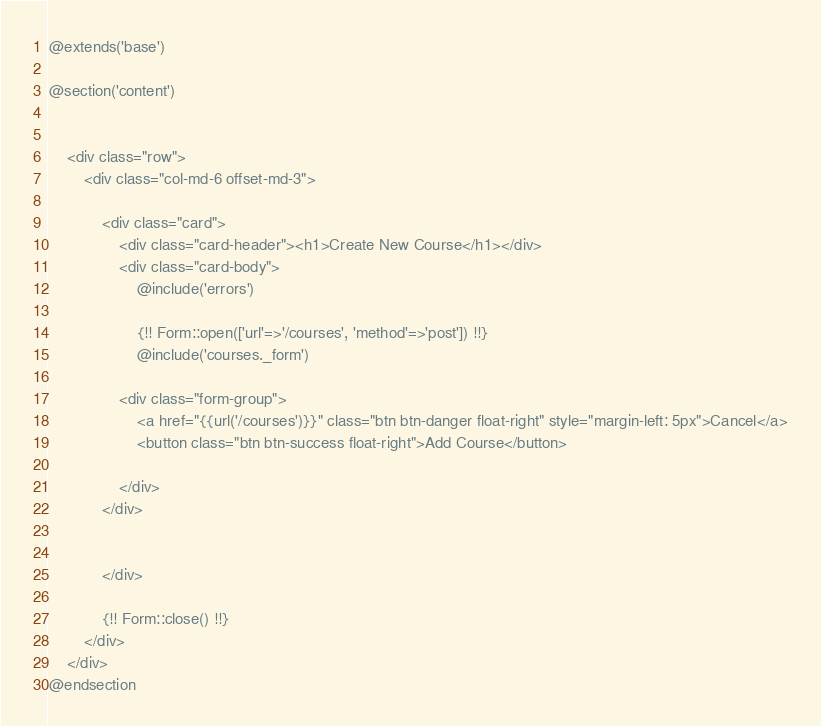<code> <loc_0><loc_0><loc_500><loc_500><_PHP_>@extends('base')

@section('content')
    

    <div class="row">
        <div class="col-md-6 offset-md-3">
            
            <div class="card">
                <div class="card-header"><h1>Create New Course</h1></div>
                <div class="card-body">
                    @include('errors')

                    {!! Form::open(['url'=>'/courses', 'method'=>'post']) !!}
                    @include('courses._form')

                <div class="form-group">
                    <a href="{{url('/courses')}}" class="btn btn-danger float-right" style="margin-left: 5px">Cancel</a>
                    <button class="btn btn-success float-right">Add Course</button>
                    
                </div>
            </div>
            
                
            </div>
        
            {!! Form::close() !!}
        </div>
    </div>
@endsection</code> 